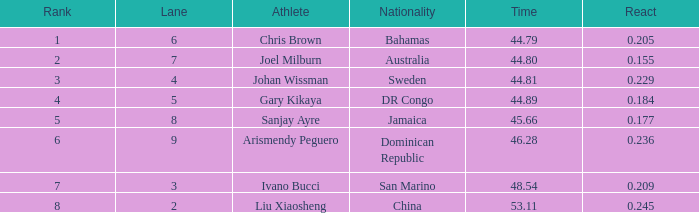What Lane has a 0.209 React entered with a Rank entry that is larger than 6? 2.0. 